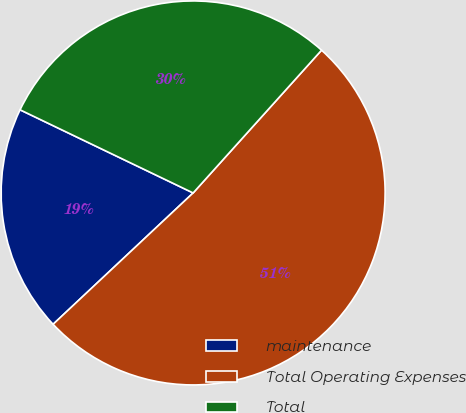Convert chart. <chart><loc_0><loc_0><loc_500><loc_500><pie_chart><fcel>maintenance<fcel>Total Operating Expenses<fcel>Total<nl><fcel>19.12%<fcel>51.35%<fcel>29.53%<nl></chart> 